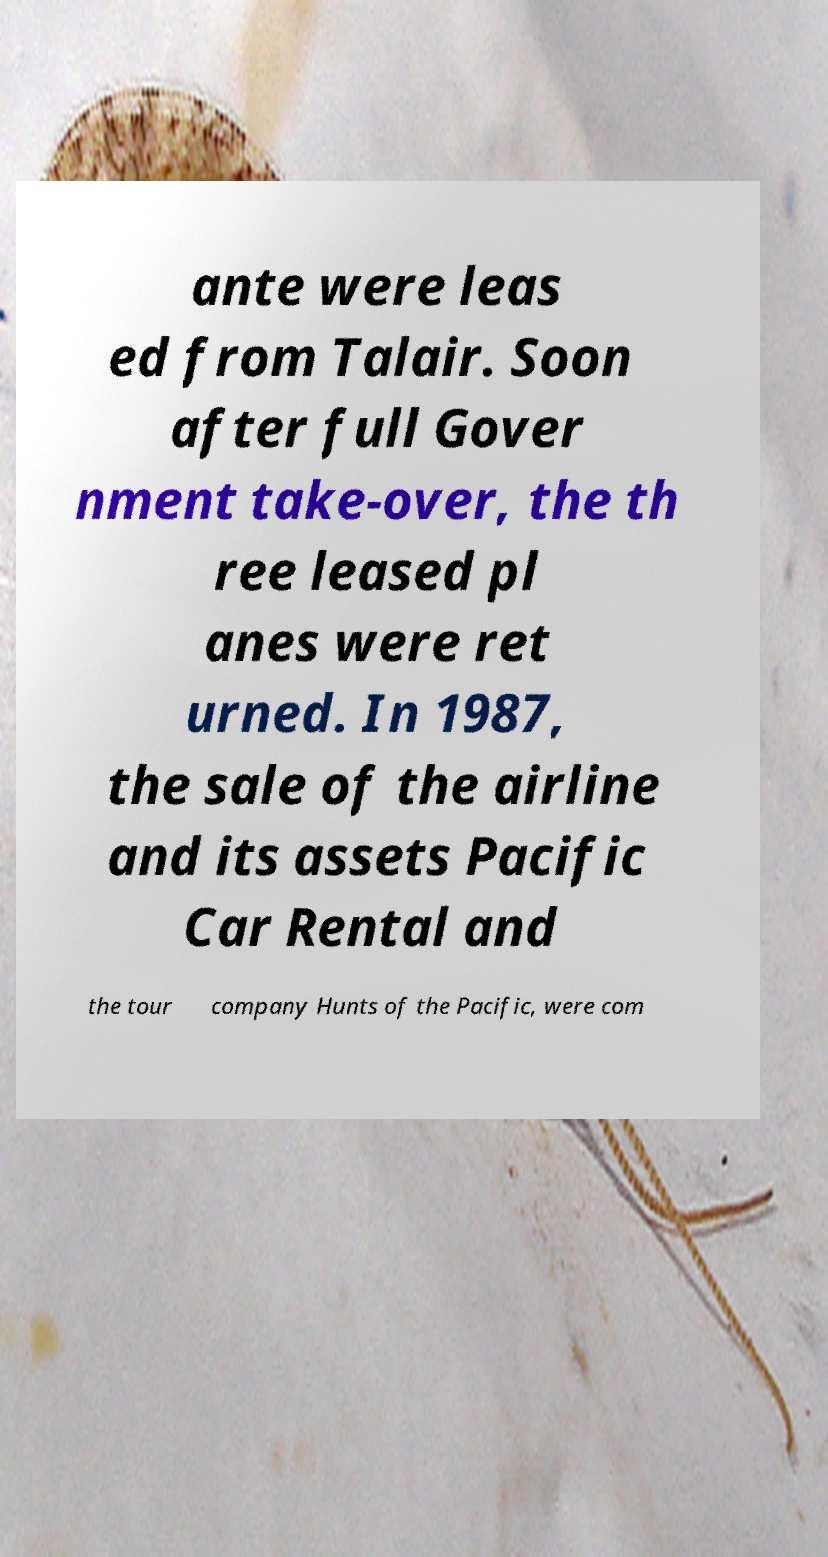For documentation purposes, I need the text within this image transcribed. Could you provide that? ante were leas ed from Talair. Soon after full Gover nment take-over, the th ree leased pl anes were ret urned. In 1987, the sale of the airline and its assets Pacific Car Rental and the tour company Hunts of the Pacific, were com 